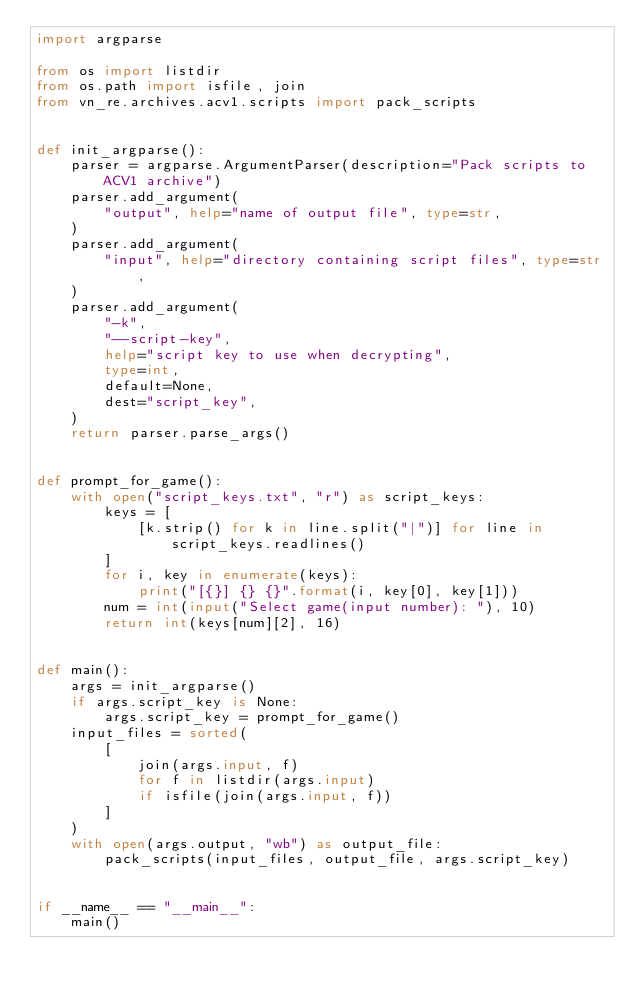<code> <loc_0><loc_0><loc_500><loc_500><_Python_>import argparse

from os import listdir
from os.path import isfile, join
from vn_re.archives.acv1.scripts import pack_scripts


def init_argparse():
    parser = argparse.ArgumentParser(description="Pack scripts to ACV1 archive")
    parser.add_argument(
        "output", help="name of output file", type=str,
    )
    parser.add_argument(
        "input", help="directory containing script files", type=str,
    )
    parser.add_argument(
        "-k",
        "--script-key",
        help="script key to use when decrypting",
        type=int,
        default=None,
        dest="script_key",
    )
    return parser.parse_args()


def prompt_for_game():
    with open("script_keys.txt", "r") as script_keys:
        keys = [
            [k.strip() for k in line.split("|")] for line in script_keys.readlines()
        ]
        for i, key in enumerate(keys):
            print("[{}] {} {}".format(i, key[0], key[1]))
        num = int(input("Select game(input number): "), 10)
        return int(keys[num][2], 16)


def main():
    args = init_argparse()
    if args.script_key is None:
        args.script_key = prompt_for_game()
    input_files = sorted(
        [
            join(args.input, f)
            for f in listdir(args.input)
            if isfile(join(args.input, f))
        ]
    )
    with open(args.output, "wb") as output_file:
        pack_scripts(input_files, output_file, args.script_key)


if __name__ == "__main__":
    main()
</code> 